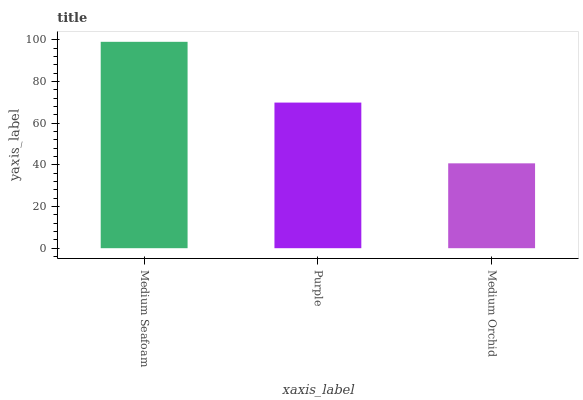Is Purple the minimum?
Answer yes or no. No. Is Purple the maximum?
Answer yes or no. No. Is Medium Seafoam greater than Purple?
Answer yes or no. Yes. Is Purple less than Medium Seafoam?
Answer yes or no. Yes. Is Purple greater than Medium Seafoam?
Answer yes or no. No. Is Medium Seafoam less than Purple?
Answer yes or no. No. Is Purple the high median?
Answer yes or no. Yes. Is Purple the low median?
Answer yes or no. Yes. Is Medium Orchid the high median?
Answer yes or no. No. Is Medium Orchid the low median?
Answer yes or no. No. 